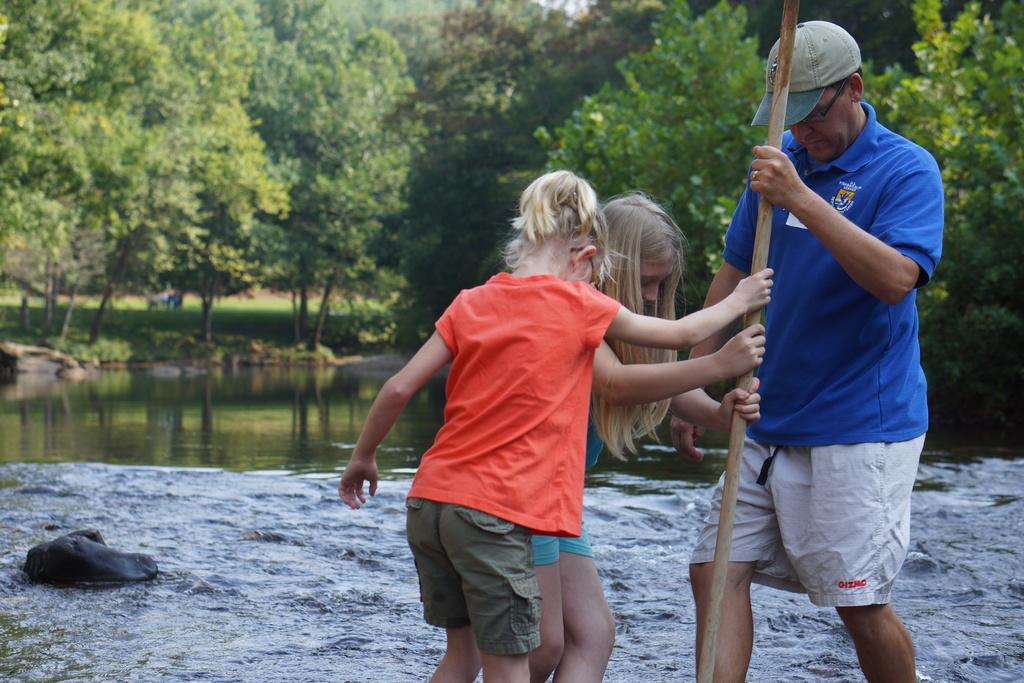Who is present in the image? There is a man and two children in the image. What are the man and children holding in the image? The man and children are holding a stick in the image. Can you describe the man's appearance? The man is wearing a cap and specs in the image. What can be seen in the background of the image? There is water, rocks, and trees in the background of the image. What size committee is present in the image? There is no committee present in the image; it features a man and two children holding a stick. What does the man in the image regret? There is no indication of regret in the image, as it shows a man and two children holding a stick with a background of water, rocks, and trees. 